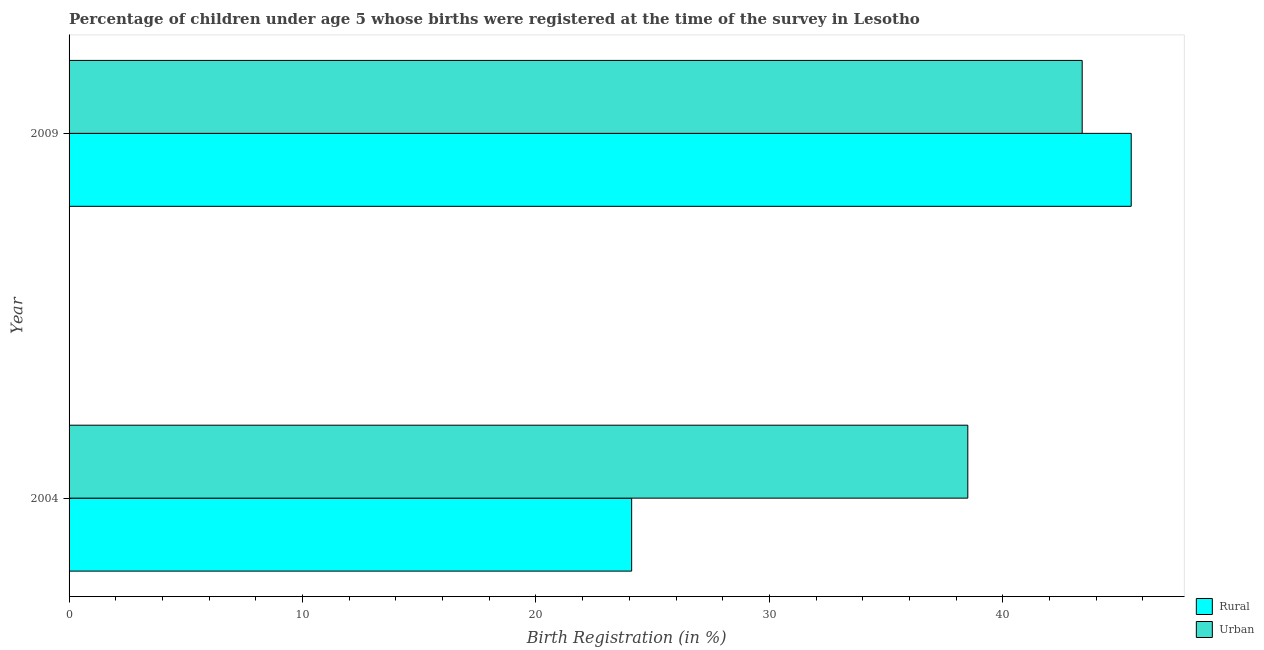What is the label of the 2nd group of bars from the top?
Give a very brief answer. 2004. In how many cases, is the number of bars for a given year not equal to the number of legend labels?
Keep it short and to the point. 0. What is the rural birth registration in 2004?
Your answer should be compact. 24.1. Across all years, what is the maximum urban birth registration?
Keep it short and to the point. 43.4. Across all years, what is the minimum urban birth registration?
Your answer should be very brief. 38.5. In which year was the rural birth registration maximum?
Ensure brevity in your answer.  2009. What is the total urban birth registration in the graph?
Offer a very short reply. 81.9. What is the difference between the rural birth registration in 2004 and that in 2009?
Your answer should be very brief. -21.4. What is the difference between the rural birth registration in 2009 and the urban birth registration in 2004?
Your answer should be very brief. 7. What is the average urban birth registration per year?
Your answer should be compact. 40.95. In how many years, is the urban birth registration greater than 26 %?
Offer a terse response. 2. What is the ratio of the urban birth registration in 2004 to that in 2009?
Make the answer very short. 0.89. Is the difference between the rural birth registration in 2004 and 2009 greater than the difference between the urban birth registration in 2004 and 2009?
Give a very brief answer. No. What does the 2nd bar from the top in 2004 represents?
Keep it short and to the point. Rural. What does the 2nd bar from the bottom in 2009 represents?
Your response must be concise. Urban. How many bars are there?
Make the answer very short. 4. Are all the bars in the graph horizontal?
Provide a succinct answer. Yes. How many years are there in the graph?
Your answer should be compact. 2. What is the difference between two consecutive major ticks on the X-axis?
Offer a very short reply. 10. Are the values on the major ticks of X-axis written in scientific E-notation?
Provide a short and direct response. No. Does the graph contain grids?
Provide a succinct answer. No. Where does the legend appear in the graph?
Make the answer very short. Bottom right. What is the title of the graph?
Offer a very short reply. Percentage of children under age 5 whose births were registered at the time of the survey in Lesotho. Does "Borrowers" appear as one of the legend labels in the graph?
Ensure brevity in your answer.  No. What is the label or title of the X-axis?
Keep it short and to the point. Birth Registration (in %). What is the label or title of the Y-axis?
Give a very brief answer. Year. What is the Birth Registration (in %) in Rural in 2004?
Ensure brevity in your answer.  24.1. What is the Birth Registration (in %) in Urban in 2004?
Your answer should be very brief. 38.5. What is the Birth Registration (in %) of Rural in 2009?
Make the answer very short. 45.5. What is the Birth Registration (in %) in Urban in 2009?
Your answer should be compact. 43.4. Across all years, what is the maximum Birth Registration (in %) in Rural?
Give a very brief answer. 45.5. Across all years, what is the maximum Birth Registration (in %) in Urban?
Give a very brief answer. 43.4. Across all years, what is the minimum Birth Registration (in %) of Rural?
Provide a succinct answer. 24.1. Across all years, what is the minimum Birth Registration (in %) of Urban?
Ensure brevity in your answer.  38.5. What is the total Birth Registration (in %) in Rural in the graph?
Provide a succinct answer. 69.6. What is the total Birth Registration (in %) of Urban in the graph?
Offer a terse response. 81.9. What is the difference between the Birth Registration (in %) of Rural in 2004 and that in 2009?
Keep it short and to the point. -21.4. What is the difference between the Birth Registration (in %) of Rural in 2004 and the Birth Registration (in %) of Urban in 2009?
Make the answer very short. -19.3. What is the average Birth Registration (in %) of Rural per year?
Make the answer very short. 34.8. What is the average Birth Registration (in %) of Urban per year?
Your answer should be compact. 40.95. In the year 2004, what is the difference between the Birth Registration (in %) of Rural and Birth Registration (in %) of Urban?
Your response must be concise. -14.4. What is the ratio of the Birth Registration (in %) of Rural in 2004 to that in 2009?
Offer a terse response. 0.53. What is the ratio of the Birth Registration (in %) of Urban in 2004 to that in 2009?
Offer a terse response. 0.89. What is the difference between the highest and the second highest Birth Registration (in %) in Rural?
Provide a short and direct response. 21.4. What is the difference between the highest and the lowest Birth Registration (in %) of Rural?
Offer a terse response. 21.4. What is the difference between the highest and the lowest Birth Registration (in %) in Urban?
Make the answer very short. 4.9. 